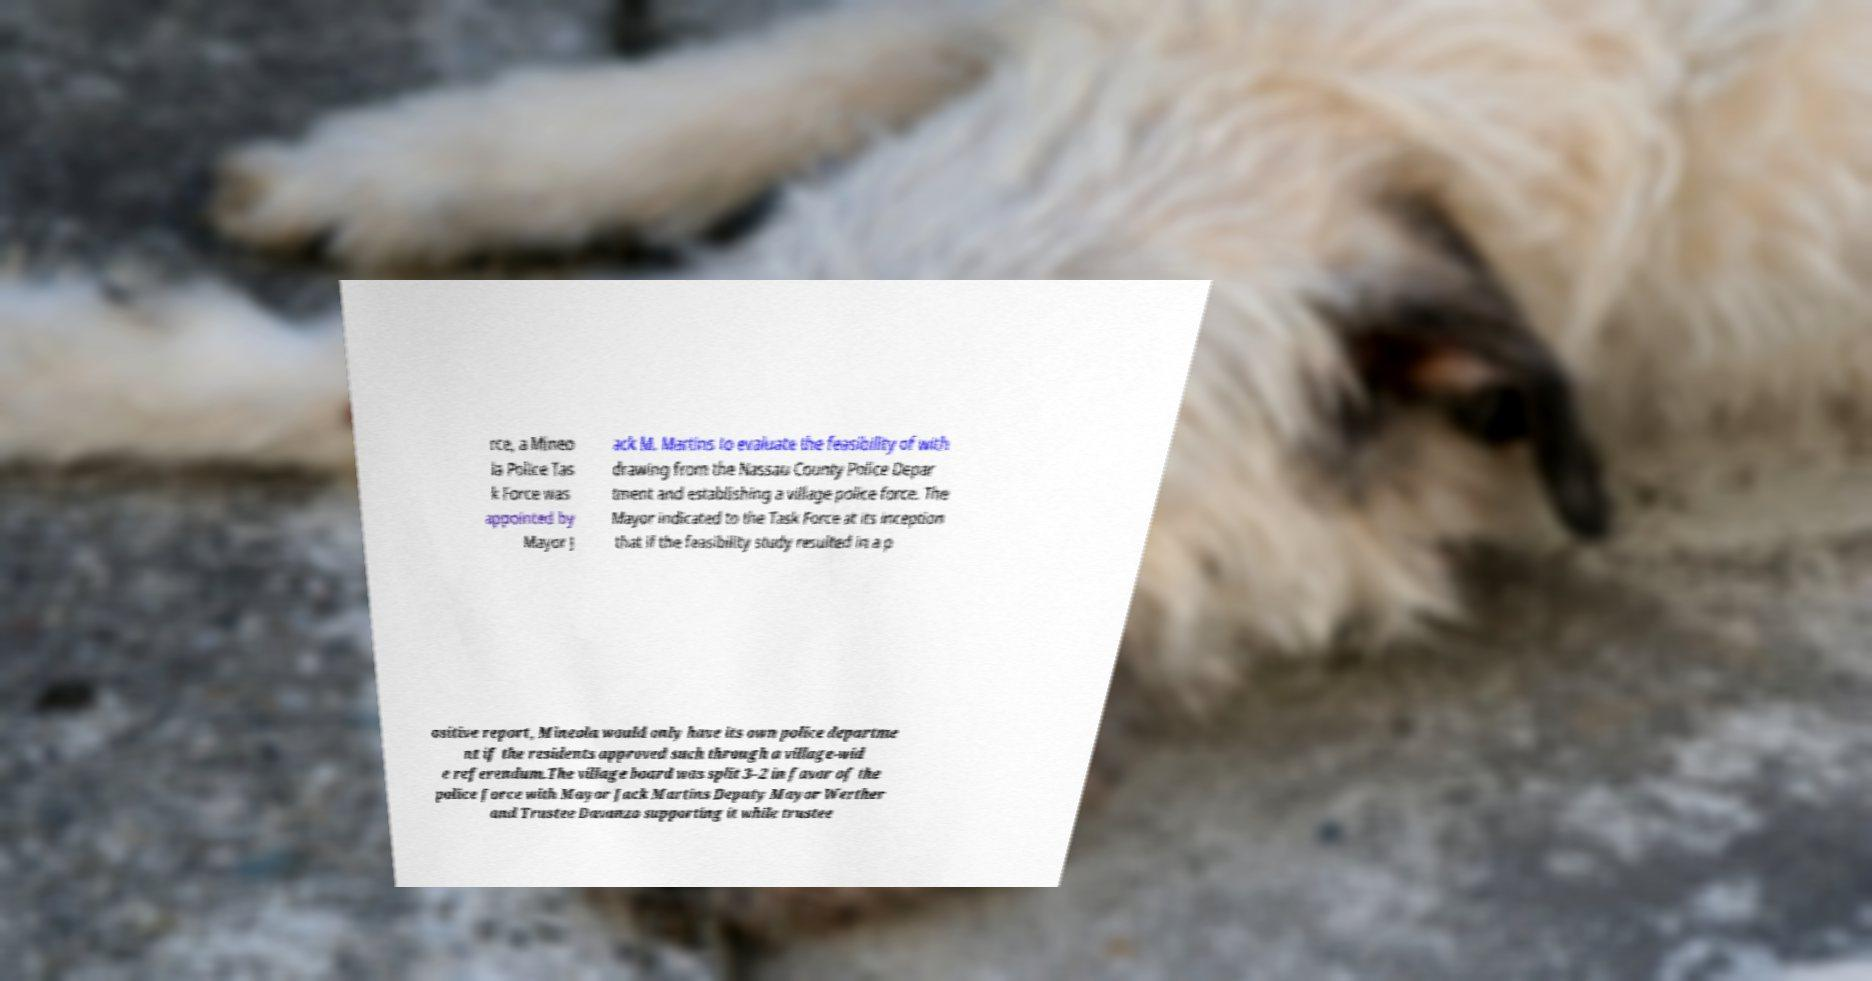Could you assist in decoding the text presented in this image and type it out clearly? rce, a Mineo la Police Tas k Force was appointed by Mayor J ack M. Martins to evaluate the feasibility of with drawing from the Nassau County Police Depar tment and establishing a village police force. The Mayor indicated to the Task Force at its inception that if the feasibility study resulted in a p ositive report, Mineola would only have its own police departme nt if the residents approved such through a village-wid e referendum.The village board was split 3–2 in favor of the police force with Mayor Jack Martins Deputy Mayor Werther and Trustee Davanzo supporting it while trustee 